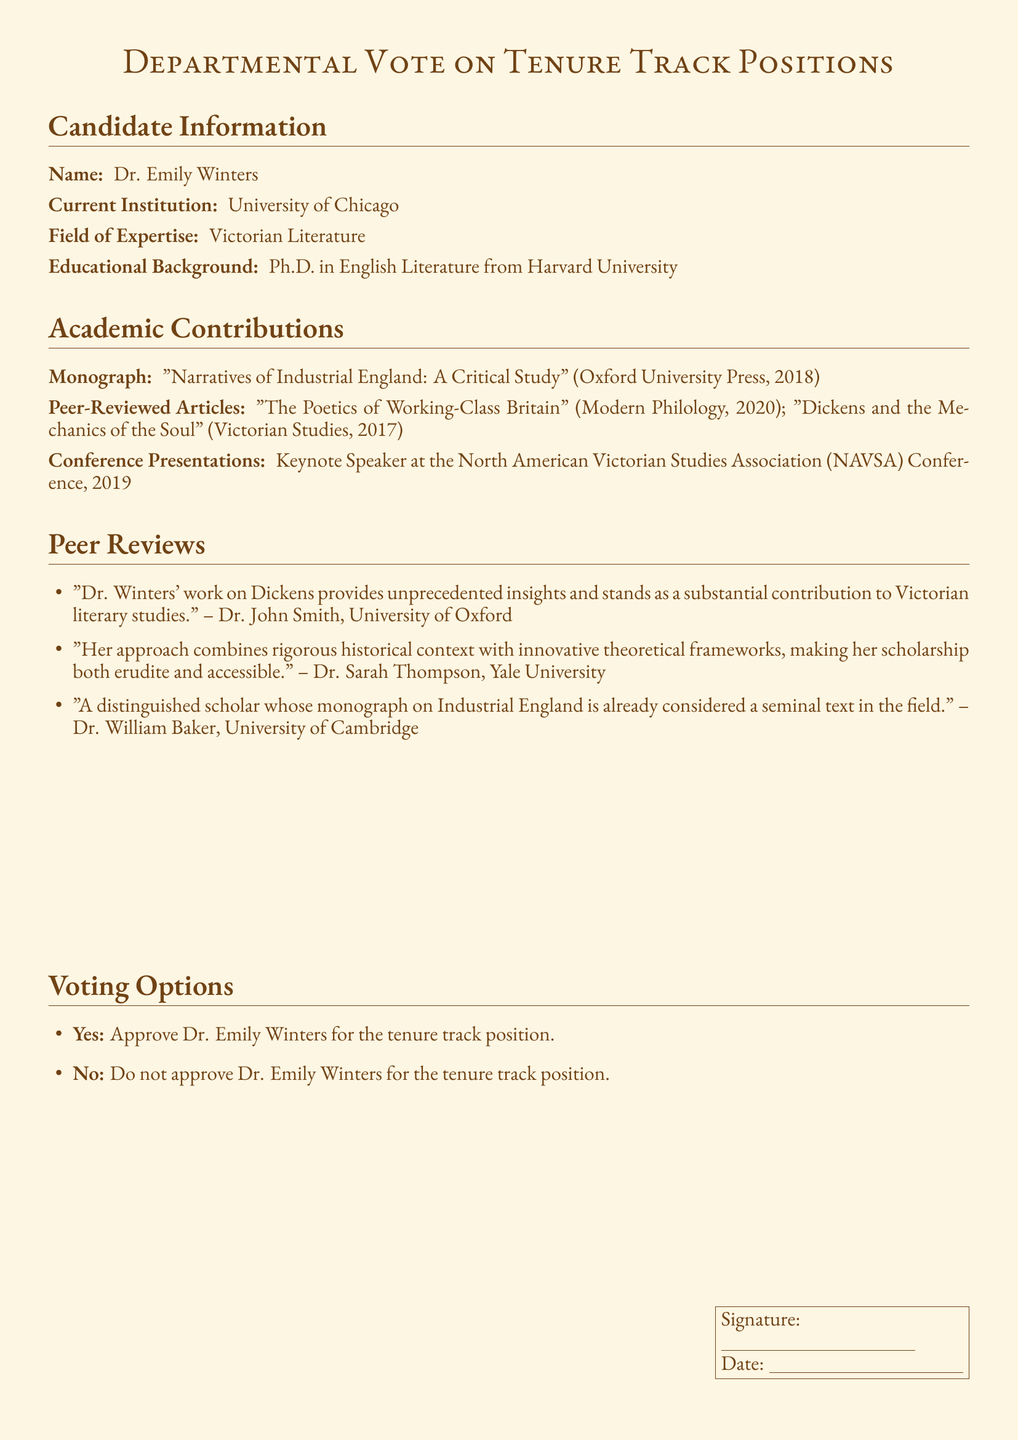What is the name of the candidate? The document states the candidate's name as Dr. Emily Winters.
Answer: Dr. Emily Winters What is Dr. Winters' current institution? The document lists her current institution as the University of Chicago.
Answer: University of Chicago What is the title of Dr. Winters' monograph? The candidate's monograph is titled "Narratives of Industrial England: A Critical Study".
Answer: "Narratives of Industrial England: A Critical Study" In what year was Dr. Winters' monograph published? The document mentions that her monograph was published in 2018.
Answer: 2018 How many peer-reviewed articles has Dr. Winters authored? The document lists two peer-reviewed articles written by Dr. Winters.
Answer: 2 Who was the keynote speaker at the 2019 NAVSA Conference? The document identifies Dr. Winters as the keynote speaker at that conference.
Answer: Dr. Emily Winters Which university is Dr. John Smith affiliated with? The document states Dr. John Smith is from the University of Oxford.
Answer: University of Oxford What is the voting option for approving Dr. Winters? The document states that the approval option is "Yes".
Answer: Yes What is the alternative voting option presented in the document? The alternative voting option presented is "No".
Answer: No What is required for the vote to be validated? The document specifies that a signature and date are required for validation.
Answer: Signature and Date 